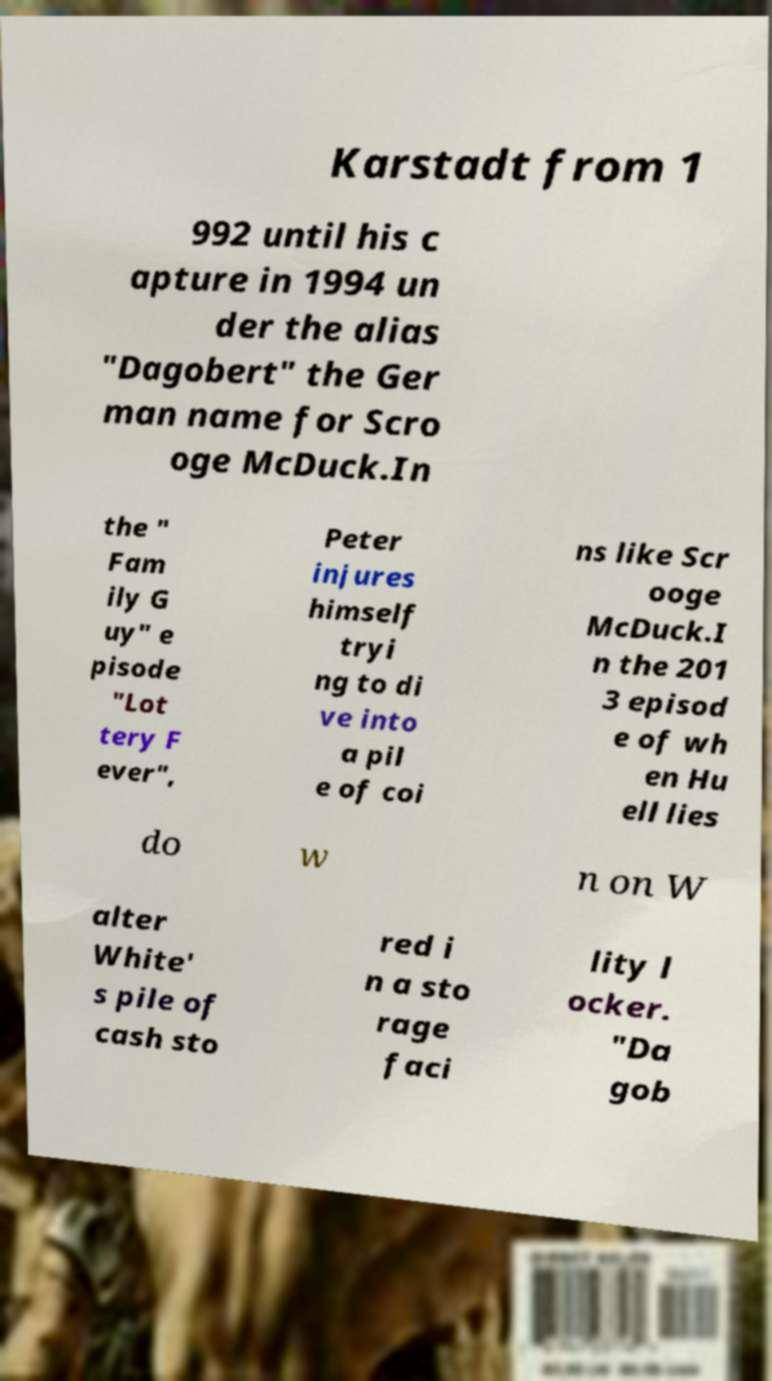Please read and relay the text visible in this image. What does it say? Karstadt from 1 992 until his c apture in 1994 un der the alias "Dagobert" the Ger man name for Scro oge McDuck.In the " Fam ily G uy" e pisode "Lot tery F ever", Peter injures himself tryi ng to di ve into a pil e of coi ns like Scr ooge McDuck.I n the 201 3 episod e of wh en Hu ell lies do w n on W alter White' s pile of cash sto red i n a sto rage faci lity l ocker. "Da gob 